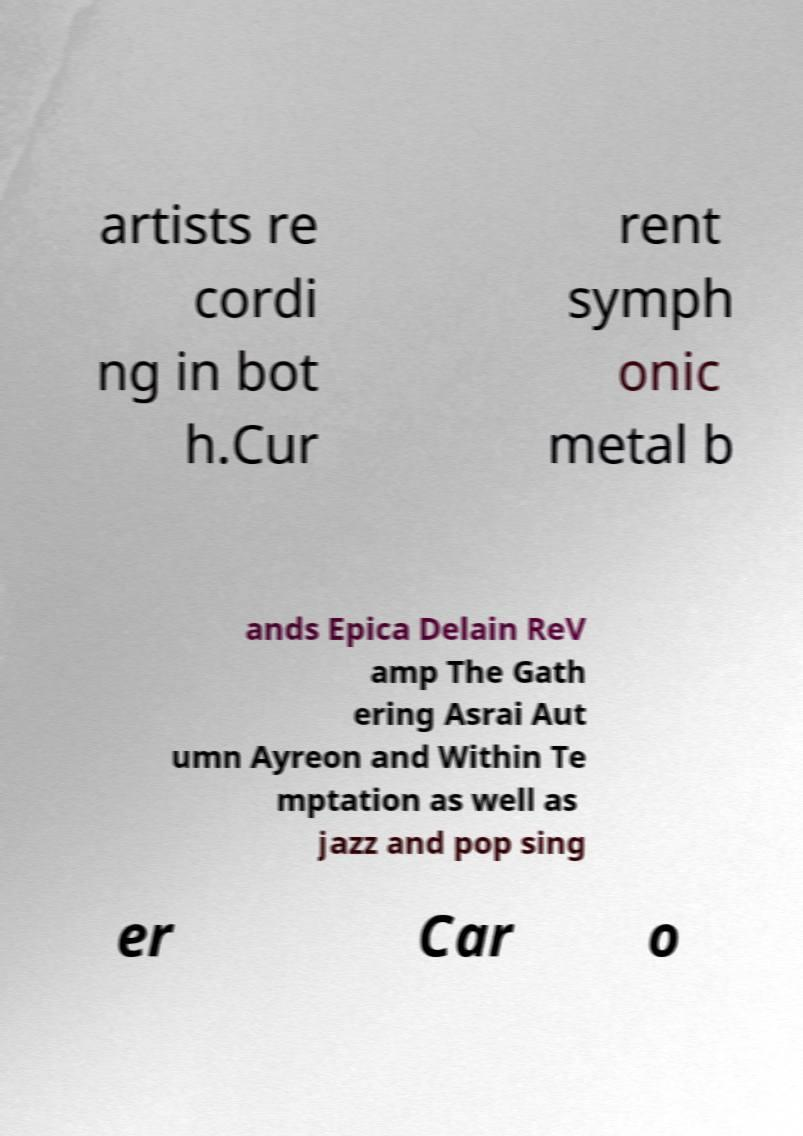Please identify and transcribe the text found in this image. artists re cordi ng in bot h.Cur rent symph onic metal b ands Epica Delain ReV amp The Gath ering Asrai Aut umn Ayreon and Within Te mptation as well as jazz and pop sing er Car o 